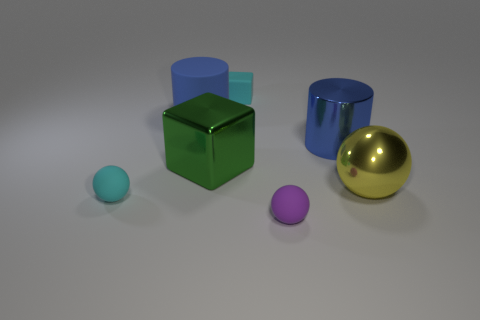Add 1 large yellow things. How many objects exist? 8 Subtract all cylinders. How many objects are left? 5 Subtract all large metal balls. Subtract all yellow spheres. How many objects are left? 5 Add 4 blue cylinders. How many blue cylinders are left? 6 Add 5 cyan rubber things. How many cyan rubber things exist? 7 Subtract 0 blue spheres. How many objects are left? 7 